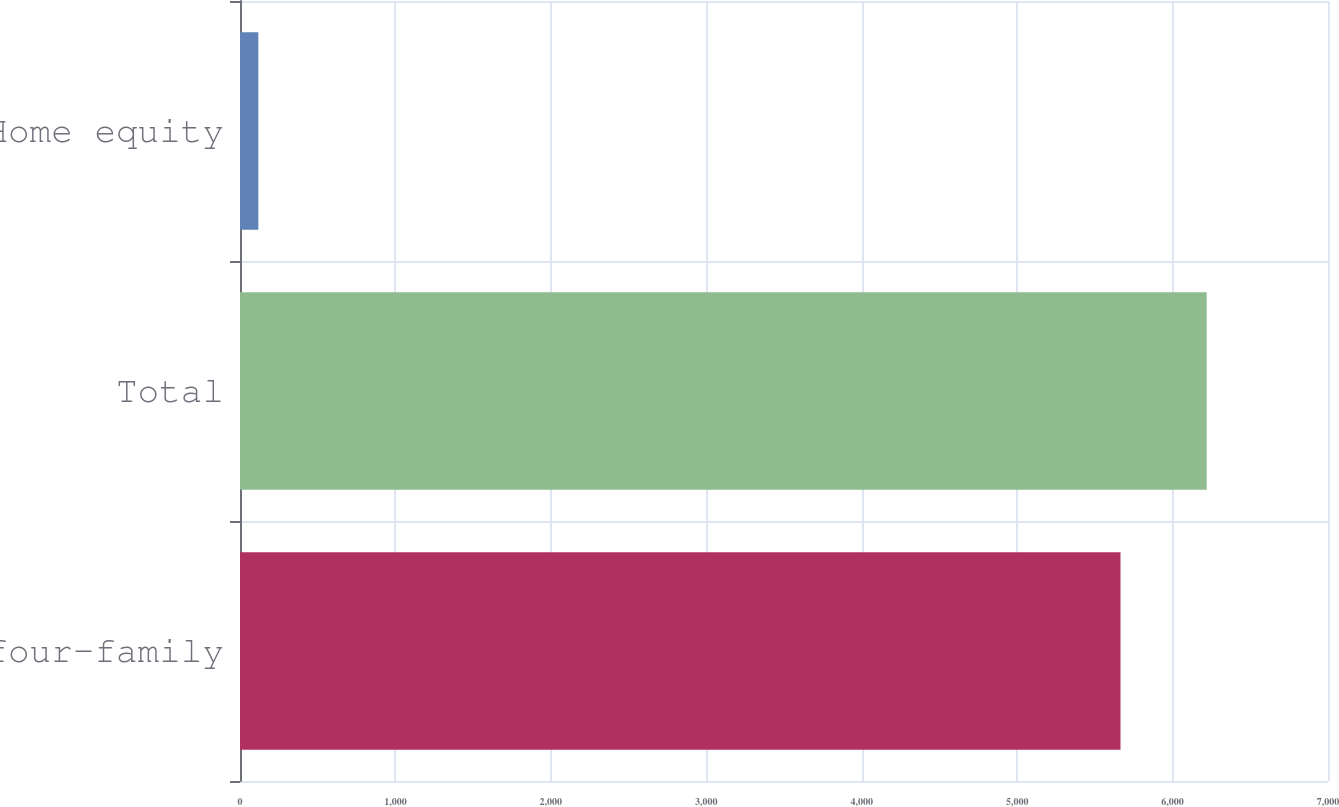<chart> <loc_0><loc_0><loc_500><loc_500><bar_chart><fcel>One- to four-family<fcel>Total<fcel>Home equity<nl><fcel>5665<fcel>6219.7<fcel>118<nl></chart> 